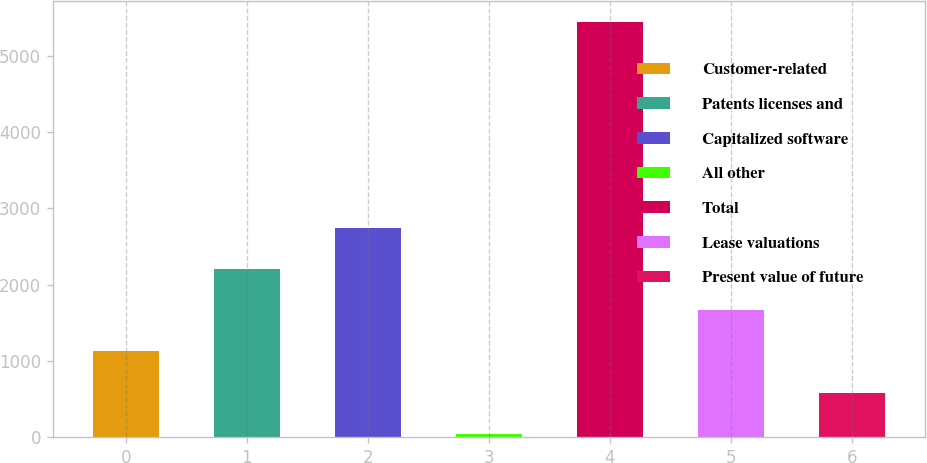Convert chart. <chart><loc_0><loc_0><loc_500><loc_500><bar_chart><fcel>Customer-related<fcel>Patents licenses and<fcel>Capitalized software<fcel>All other<fcel>Total<fcel>Lease valuations<fcel>Present value of future<nl><fcel>1123.8<fcel>2206.6<fcel>2748<fcel>41<fcel>5455<fcel>1665.2<fcel>582.4<nl></chart> 